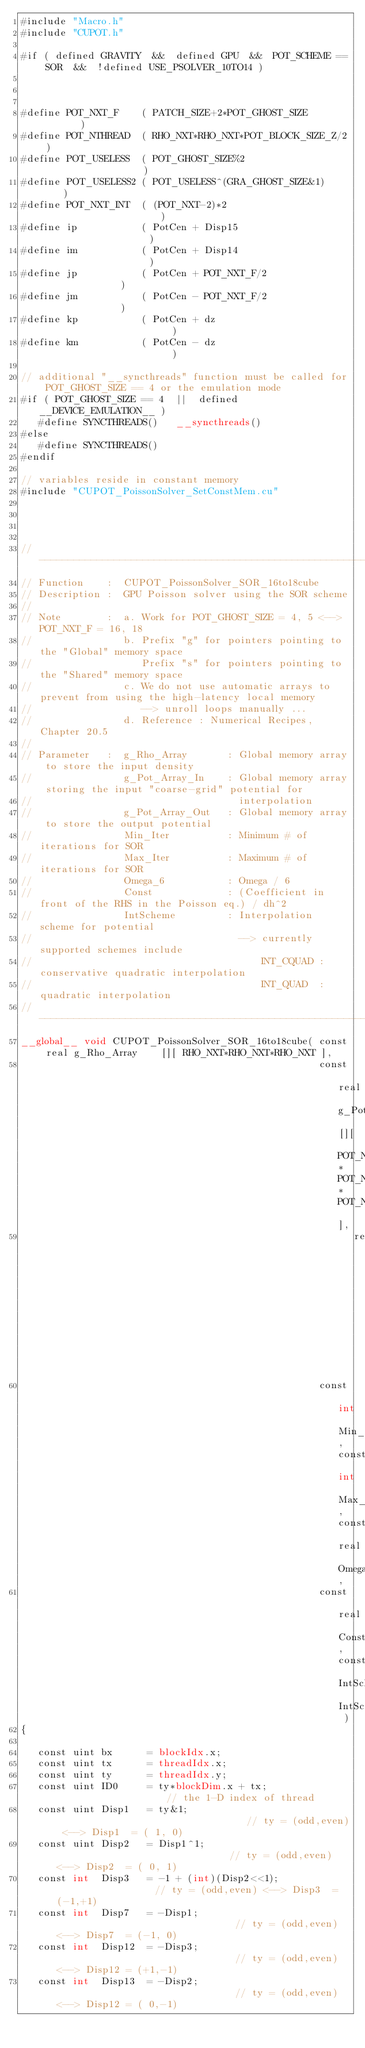Convert code to text. <code><loc_0><loc_0><loc_500><loc_500><_Cuda_>#include "Macro.h"
#include "CUPOT.h"

#if ( defined GRAVITY  &&  defined GPU  &&  POT_SCHEME == SOR  &&  !defined USE_PSOLVER_10TO14 )



#define POT_NXT_F    ( PATCH_SIZE+2*POT_GHOST_SIZE        )
#define POT_NTHREAD  ( RHO_NXT*RHO_NXT*POT_BLOCK_SIZE_Z/2 )
#define POT_USELESS  ( POT_GHOST_SIZE%2                   )
#define POT_USELESS2 ( POT_USELESS^(GRA_GHOST_SIZE&1)     )
#define POT_NXT_INT  ( (POT_NXT-2)*2                      )
#define ip           ( PotCen + Disp15                    )
#define im           ( PotCen + Disp14                    )
#define jp           ( PotCen + POT_NXT_F/2               )
#define jm           ( PotCen - POT_NXT_F/2               )
#define kp           ( PotCen + dz                        )
#define km           ( PotCen - dz                        )

// additional "__syncthreads" function must be called for POT_GHOST_SIZE == 4 or the emulation mode
#if ( POT_GHOST_SIZE == 4  ||  defined  __DEVICE_EMULATION__ )
   #define SYNCTHREADS()   __syncthreads()
#else
   #define SYNCTHREADS()
#endif

// variables reside in constant memory
#include "CUPOT_PoissonSolver_SetConstMem.cu"




//-------------------------------------------------------------------------------------------------------
// Function    :  CUPOT_PoissonSolver_SOR_16to18cube
// Description :  GPU Poisson solver using the SOR scheme
//
// Note        :  a. Work for POT_GHOST_SIZE = 4, 5 <--> POT_NXT_F = 16, 18
//                b. Prefix "g" for pointers pointing to the "Global" memory space
//                   Prefix "s" for pointers pointing to the "Shared" memory space
//                c. We do not use automatic arrays to prevent from using the high-latency local memory
//                   --> unroll loops manually ...
//                d. Reference : Numerical Recipes, Chapter 20.5
//
// Parameter   :  g_Rho_Array       : Global memory array to store the input density
//                g_Pot_Array_In    : Global memory array storing the input "coarse-grid" potential for
//                                    interpolation
//                g_Pot_Array_Out   : Global memory array to store the output potential
//                Min_Iter          : Minimum # of iterations for SOR
//                Max_Iter          : Maximum # of iterations for SOR
//                Omega_6           : Omega / 6
//                Const             : (Coefficient in front of the RHS in the Poisson eq.) / dh^2
//                IntScheme         : Interpolation scheme for potential
//                                    --> currently supported schemes include
//                                        INT_CQUAD : conservative quadratic interpolation
//                                        INT_QUAD  : quadratic interpolation
//---------------------------------------------------------------------------------------------------
__global__ void CUPOT_PoissonSolver_SOR_16to18cube( const real g_Rho_Array    [][ RHO_NXT*RHO_NXT*RHO_NXT ],
                                                    const real g_Pot_Array_In [][ POT_NXT*POT_NXT*POT_NXT ],
                                                          real g_Pot_Array_Out[][ GRA_NXT*GRA_NXT*GRA_NXT ],
                                                    const int Min_Iter, const int Max_Iter, const real Omega_6,
                                                    const real Const, const IntScheme_t IntScheme )
{

   const uint bx      = blockIdx.x;
   const uint tx      = threadIdx.x;
   const uint ty      = threadIdx.y;
   const uint ID0     = ty*blockDim.x + tx;                    // the 1-D index of thread
   const uint Disp1   = ty&1;                                  // ty = (odd,even) <--> Disp1  = ( 1, 0)
   const uint Disp2   = Disp1^1;                               // ty = (odd,even) <--> Disp2  = ( 0, 1)
   const int  Disp3   = -1 + (int)(Disp2<<1);                  // ty = (odd,even) <--> Disp3  = (-1,+1)
   const int  Disp7   = -Disp1;                                // ty = (odd,even) <--> Disp7  = (-1, 0)
   const int  Disp12  = -Disp3;                                // ty = (odd,even) <--> Disp12 = (+1,-1)
   const int  Disp13  = -Disp2;                                // ty = (odd,even) <--> Disp12 = ( 0,-1)</code> 